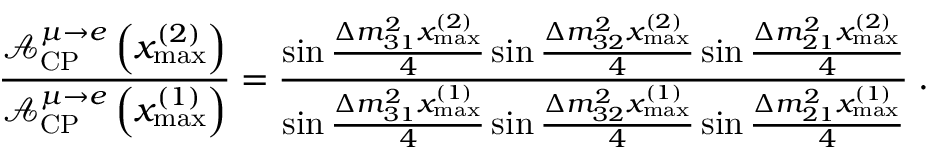Convert formula to latex. <formula><loc_0><loc_0><loc_500><loc_500>\frac { \mathcal { A } _ { C P } ^ { \mu \rightarrow e } \left ( x _ { \max } ^ { ( 2 ) } \right ) } { \mathcal { A } _ { C P } ^ { \mu \rightarrow e } \left ( x _ { \max } ^ { ( 1 ) } \right ) } = \frac { \sin \frac { \Delta m _ { 3 1 } ^ { 2 } x _ { \max } ^ { ( 2 ) } } { 4 } \sin \frac { \Delta m _ { 3 2 } ^ { 2 } x _ { \max } ^ { ( 2 ) } } { 4 } \sin \frac { \Delta m _ { 2 1 } ^ { 2 } x _ { \max } ^ { ( 2 ) } } { 4 } } { \sin \frac { \Delta m _ { 3 1 } ^ { 2 } x _ { \max } ^ { ( 1 ) } } { 4 } \sin \frac { \Delta m _ { 3 2 } ^ { 2 } x _ { \max } ^ { ( 1 ) } } { 4 } \sin \frac { \Delta m _ { 2 1 } ^ { 2 } x _ { \max } ^ { ( 1 ) } } { 4 } } \, .</formula> 